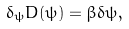Convert formula to latex. <formula><loc_0><loc_0><loc_500><loc_500>\delta _ { \psi } D ( \psi ) = \beta \delta \psi ,</formula> 